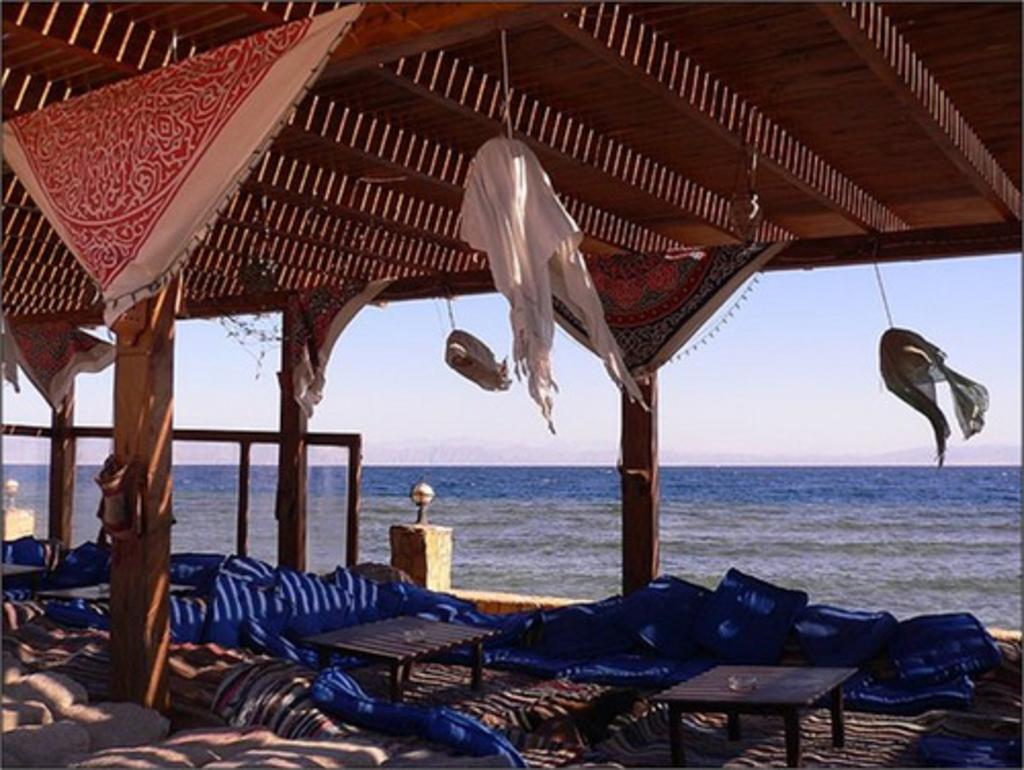What type of furniture can be seen in the image? There are tables in the image. What color is present among the objects in the image? There are blue color objects in the image. What is being hung in the image? Clothes are hanged in the image. What can be seen in the background of the image? Water and the sky are visible in the background of the image. How many robins are perched on the clothes in the image? There are no robins present in the image; only tables, blue objects, clothes, water, and the sky are visible. Can you tell me the purpose of the lizards in the image? There are no lizards present in the image, so it is not possible to determine their purpose. 